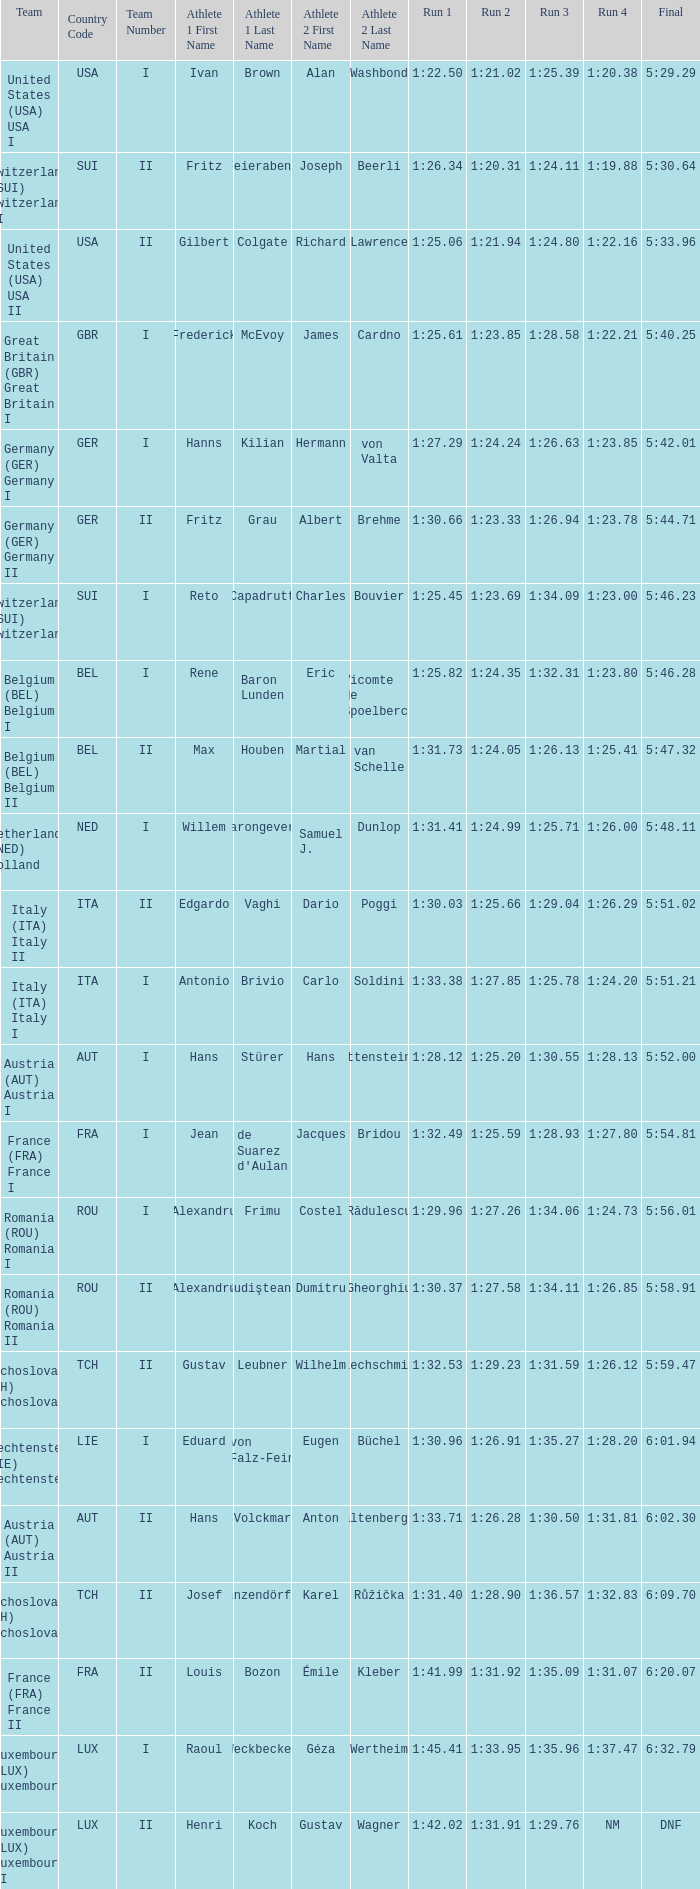Which Run 4 has Athletes of alexandru frimu & costel rădulescu? 1:24.73. 